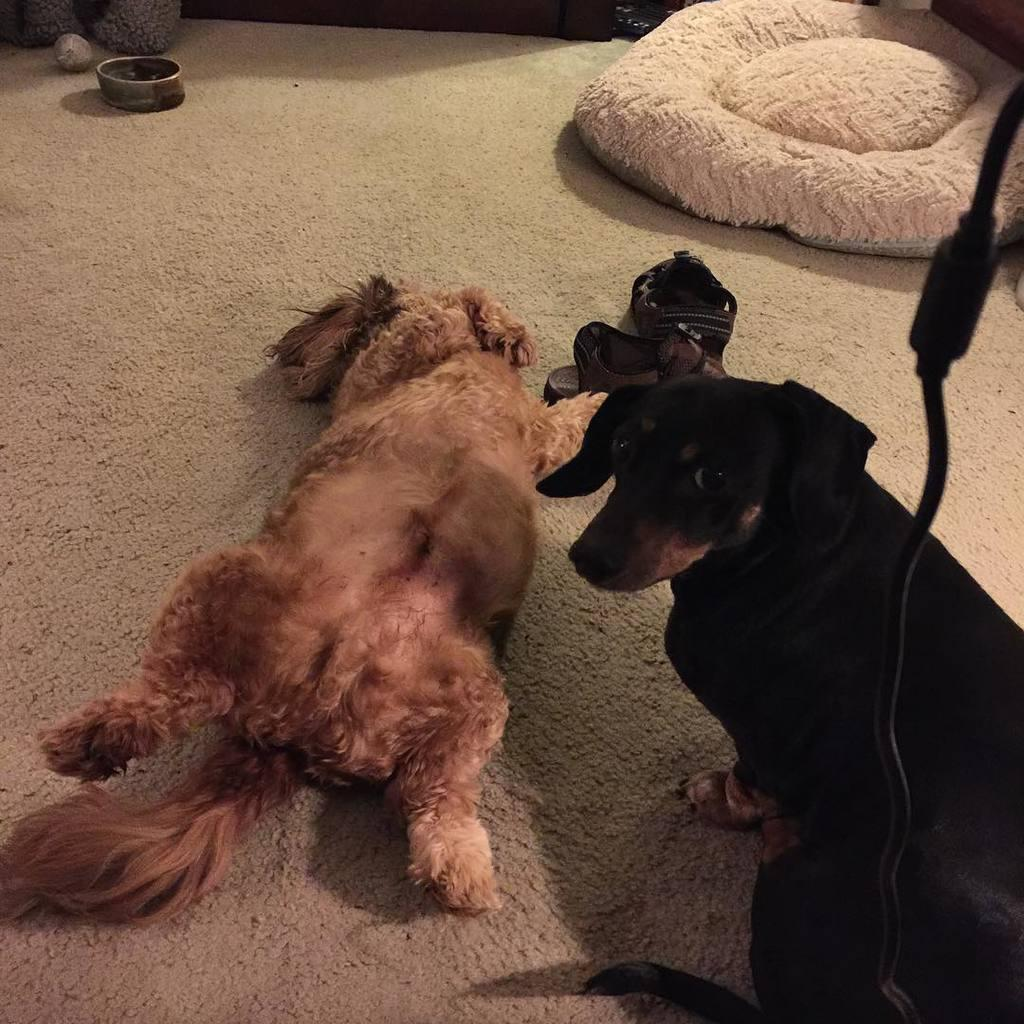What type of footwear is on the carpet in the image? There are sandals on the carpet. What other objects or living beings are on the carpet? There are dogs on the carpet. What is the purpose of the bowl on the carpet? The purpose of the bowl on the carpet is not specified in the image. What type of pies are being served on the carpet? There are no pies present in the image; it features sandals, dogs, and a bowl on the carpet. What is the chance of winning a prize in the image? There is no indication of a prize or a game in the image, so it's not possible to determine the chance of winning a prize. 